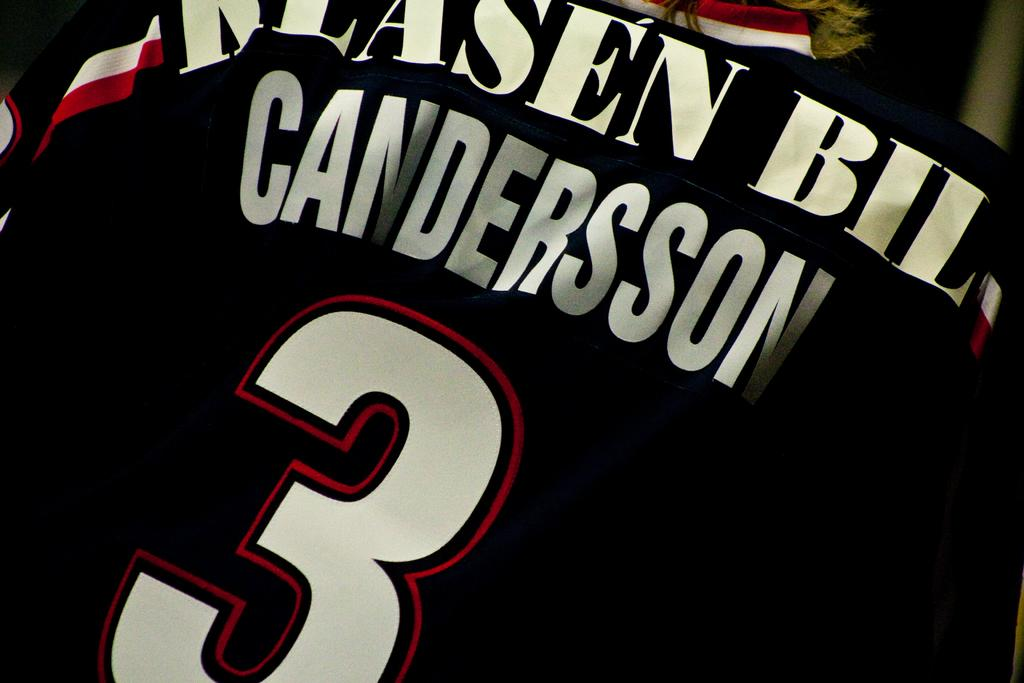<image>
Describe the image concisely. Black sports jersey with Candersson in white letters. 